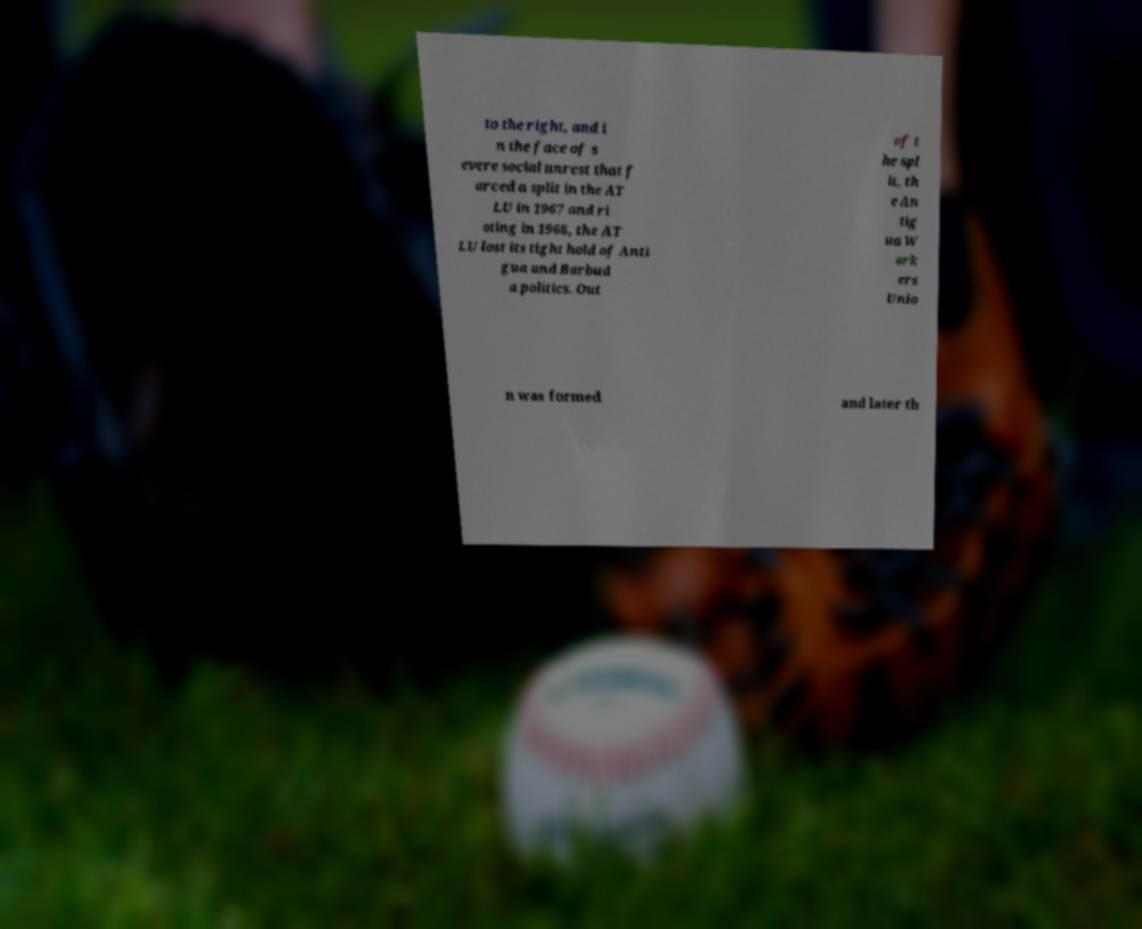Can you accurately transcribe the text from the provided image for me? to the right, and i n the face of s evere social unrest that f orced a split in the AT LU in 1967 and ri oting in 1968, the AT LU lost its tight hold of Anti gua and Barbud a politics. Out of t he spl it, th e An tig ua W ork ers Unio n was formed and later th 